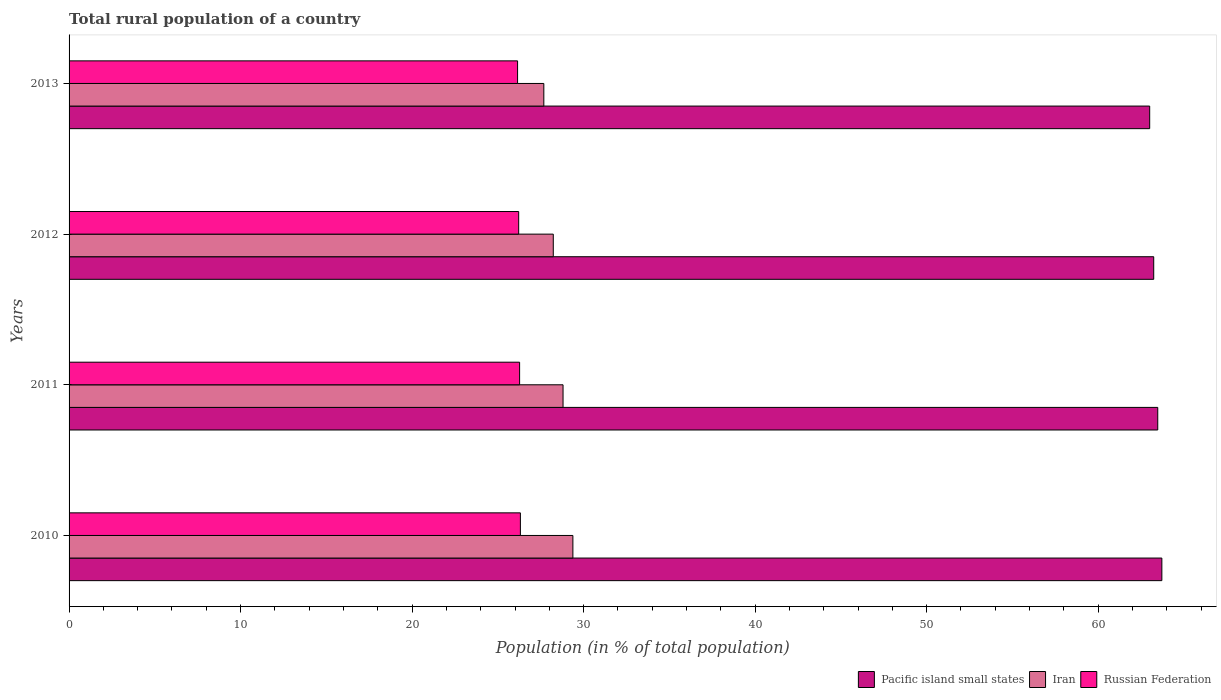What is the rural population in Pacific island small states in 2010?
Your answer should be compact. 63.71. Across all years, what is the maximum rural population in Russian Federation?
Your response must be concise. 26.31. Across all years, what is the minimum rural population in Iran?
Make the answer very short. 27.68. In which year was the rural population in Pacific island small states maximum?
Offer a very short reply. 2010. What is the total rural population in Iran in the graph?
Ensure brevity in your answer.  114.09. What is the difference between the rural population in Russian Federation in 2010 and that in 2013?
Your response must be concise. 0.16. What is the difference between the rural population in Russian Federation in 2011 and the rural population in Pacific island small states in 2013?
Keep it short and to the point. -36.73. What is the average rural population in Russian Federation per year?
Provide a succinct answer. 26.24. In the year 2012, what is the difference between the rural population in Pacific island small states and rural population in Iran?
Your answer should be very brief. 35.01. In how many years, is the rural population in Pacific island small states greater than 62 %?
Your answer should be compact. 4. What is the ratio of the rural population in Russian Federation in 2012 to that in 2013?
Offer a terse response. 1. Is the rural population in Pacific island small states in 2012 less than that in 2013?
Your response must be concise. No. What is the difference between the highest and the second highest rural population in Pacific island small states?
Make the answer very short. 0.24. What is the difference between the highest and the lowest rural population in Pacific island small states?
Offer a terse response. 0.71. In how many years, is the rural population in Pacific island small states greater than the average rural population in Pacific island small states taken over all years?
Provide a short and direct response. 2. Is the sum of the rural population in Iran in 2010 and 2012 greater than the maximum rural population in Pacific island small states across all years?
Make the answer very short. No. What does the 3rd bar from the top in 2010 represents?
Your answer should be compact. Pacific island small states. What does the 2nd bar from the bottom in 2010 represents?
Offer a terse response. Iran. How many bars are there?
Give a very brief answer. 12. Are all the bars in the graph horizontal?
Your answer should be very brief. Yes. Are the values on the major ticks of X-axis written in scientific E-notation?
Offer a very short reply. No. Does the graph contain any zero values?
Your answer should be compact. No. Does the graph contain grids?
Make the answer very short. No. Where does the legend appear in the graph?
Your answer should be very brief. Bottom right. How are the legend labels stacked?
Offer a terse response. Horizontal. What is the title of the graph?
Give a very brief answer. Total rural population of a country. What is the label or title of the X-axis?
Ensure brevity in your answer.  Population (in % of total population). What is the Population (in % of total population) in Pacific island small states in 2010?
Provide a succinct answer. 63.71. What is the Population (in % of total population) in Iran in 2010?
Your answer should be compact. 29.37. What is the Population (in % of total population) in Russian Federation in 2010?
Your response must be concise. 26.31. What is the Population (in % of total population) of Pacific island small states in 2011?
Keep it short and to the point. 63.47. What is the Population (in % of total population) of Iran in 2011?
Make the answer very short. 28.8. What is the Population (in % of total population) of Russian Federation in 2011?
Offer a terse response. 26.27. What is the Population (in % of total population) of Pacific island small states in 2012?
Offer a terse response. 63.24. What is the Population (in % of total population) in Iran in 2012?
Provide a short and direct response. 28.23. What is the Population (in % of total population) in Russian Federation in 2012?
Give a very brief answer. 26.21. What is the Population (in % of total population) in Pacific island small states in 2013?
Provide a succinct answer. 63. What is the Population (in % of total population) in Iran in 2013?
Your response must be concise. 27.68. What is the Population (in % of total population) of Russian Federation in 2013?
Ensure brevity in your answer.  26.15. Across all years, what is the maximum Population (in % of total population) in Pacific island small states?
Your answer should be compact. 63.71. Across all years, what is the maximum Population (in % of total population) of Iran?
Offer a terse response. 29.37. Across all years, what is the maximum Population (in % of total population) of Russian Federation?
Offer a very short reply. 26.31. Across all years, what is the minimum Population (in % of total population) in Pacific island small states?
Ensure brevity in your answer.  63. Across all years, what is the minimum Population (in % of total population) of Iran?
Ensure brevity in your answer.  27.68. Across all years, what is the minimum Population (in % of total population) of Russian Federation?
Offer a very short reply. 26.15. What is the total Population (in % of total population) of Pacific island small states in the graph?
Offer a terse response. 253.43. What is the total Population (in % of total population) of Iran in the graph?
Your answer should be very brief. 114.08. What is the total Population (in % of total population) in Russian Federation in the graph?
Make the answer very short. 104.94. What is the difference between the Population (in % of total population) of Pacific island small states in 2010 and that in 2011?
Give a very brief answer. 0.24. What is the difference between the Population (in % of total population) in Iran in 2010 and that in 2011?
Offer a very short reply. 0.57. What is the difference between the Population (in % of total population) of Russian Federation in 2010 and that in 2011?
Offer a terse response. 0.04. What is the difference between the Population (in % of total population) of Pacific island small states in 2010 and that in 2012?
Your answer should be compact. 0.47. What is the difference between the Population (in % of total population) in Iran in 2010 and that in 2012?
Make the answer very short. 1.14. What is the difference between the Population (in % of total population) of Russian Federation in 2010 and that in 2012?
Your answer should be very brief. 0.1. What is the difference between the Population (in % of total population) in Pacific island small states in 2010 and that in 2013?
Make the answer very short. 0.71. What is the difference between the Population (in % of total population) in Iran in 2010 and that in 2013?
Offer a very short reply. 1.69. What is the difference between the Population (in % of total population) of Russian Federation in 2010 and that in 2013?
Provide a short and direct response. 0.16. What is the difference between the Population (in % of total population) of Pacific island small states in 2011 and that in 2012?
Provide a short and direct response. 0.24. What is the difference between the Population (in % of total population) of Iran in 2011 and that in 2012?
Offer a very short reply. 0.57. What is the difference between the Population (in % of total population) of Russian Federation in 2011 and that in 2012?
Make the answer very short. 0.05. What is the difference between the Population (in % of total population) of Pacific island small states in 2011 and that in 2013?
Your response must be concise. 0.47. What is the difference between the Population (in % of total population) of Iran in 2011 and that in 2013?
Your response must be concise. 1.12. What is the difference between the Population (in % of total population) in Russian Federation in 2011 and that in 2013?
Ensure brevity in your answer.  0.12. What is the difference between the Population (in % of total population) of Pacific island small states in 2012 and that in 2013?
Provide a short and direct response. 0.23. What is the difference between the Population (in % of total population) of Iran in 2012 and that in 2013?
Make the answer very short. 0.55. What is the difference between the Population (in % of total population) of Russian Federation in 2012 and that in 2013?
Offer a terse response. 0.07. What is the difference between the Population (in % of total population) in Pacific island small states in 2010 and the Population (in % of total population) in Iran in 2011?
Offer a terse response. 34.91. What is the difference between the Population (in % of total population) of Pacific island small states in 2010 and the Population (in % of total population) of Russian Federation in 2011?
Give a very brief answer. 37.44. What is the difference between the Population (in % of total population) in Iran in 2010 and the Population (in % of total population) in Russian Federation in 2011?
Your answer should be compact. 3.11. What is the difference between the Population (in % of total population) in Pacific island small states in 2010 and the Population (in % of total population) in Iran in 2012?
Ensure brevity in your answer.  35.48. What is the difference between the Population (in % of total population) of Pacific island small states in 2010 and the Population (in % of total population) of Russian Federation in 2012?
Keep it short and to the point. 37.5. What is the difference between the Population (in % of total population) in Iran in 2010 and the Population (in % of total population) in Russian Federation in 2012?
Offer a terse response. 3.16. What is the difference between the Population (in % of total population) of Pacific island small states in 2010 and the Population (in % of total population) of Iran in 2013?
Your response must be concise. 36.03. What is the difference between the Population (in % of total population) in Pacific island small states in 2010 and the Population (in % of total population) in Russian Federation in 2013?
Offer a very short reply. 37.56. What is the difference between the Population (in % of total population) in Iran in 2010 and the Population (in % of total population) in Russian Federation in 2013?
Provide a succinct answer. 3.23. What is the difference between the Population (in % of total population) of Pacific island small states in 2011 and the Population (in % of total population) of Iran in 2012?
Keep it short and to the point. 35.24. What is the difference between the Population (in % of total population) in Pacific island small states in 2011 and the Population (in % of total population) in Russian Federation in 2012?
Give a very brief answer. 37.26. What is the difference between the Population (in % of total population) in Iran in 2011 and the Population (in % of total population) in Russian Federation in 2012?
Keep it short and to the point. 2.59. What is the difference between the Population (in % of total population) of Pacific island small states in 2011 and the Population (in % of total population) of Iran in 2013?
Give a very brief answer. 35.79. What is the difference between the Population (in % of total population) in Pacific island small states in 2011 and the Population (in % of total population) in Russian Federation in 2013?
Make the answer very short. 37.32. What is the difference between the Population (in % of total population) in Iran in 2011 and the Population (in % of total population) in Russian Federation in 2013?
Your response must be concise. 2.65. What is the difference between the Population (in % of total population) of Pacific island small states in 2012 and the Population (in % of total population) of Iran in 2013?
Keep it short and to the point. 35.56. What is the difference between the Population (in % of total population) of Pacific island small states in 2012 and the Population (in % of total population) of Russian Federation in 2013?
Keep it short and to the point. 37.09. What is the difference between the Population (in % of total population) in Iran in 2012 and the Population (in % of total population) in Russian Federation in 2013?
Make the answer very short. 2.08. What is the average Population (in % of total population) in Pacific island small states per year?
Offer a terse response. 63.36. What is the average Population (in % of total population) of Iran per year?
Provide a short and direct response. 28.52. What is the average Population (in % of total population) in Russian Federation per year?
Your answer should be very brief. 26.24. In the year 2010, what is the difference between the Population (in % of total population) in Pacific island small states and Population (in % of total population) in Iran?
Your answer should be compact. 34.34. In the year 2010, what is the difference between the Population (in % of total population) of Pacific island small states and Population (in % of total population) of Russian Federation?
Your response must be concise. 37.4. In the year 2010, what is the difference between the Population (in % of total population) of Iran and Population (in % of total population) of Russian Federation?
Provide a short and direct response. 3.06. In the year 2011, what is the difference between the Population (in % of total population) of Pacific island small states and Population (in % of total population) of Iran?
Keep it short and to the point. 34.67. In the year 2011, what is the difference between the Population (in % of total population) in Pacific island small states and Population (in % of total population) in Russian Federation?
Offer a very short reply. 37.21. In the year 2011, what is the difference between the Population (in % of total population) in Iran and Population (in % of total population) in Russian Federation?
Offer a terse response. 2.53. In the year 2012, what is the difference between the Population (in % of total population) in Pacific island small states and Population (in % of total population) in Iran?
Keep it short and to the point. 35.01. In the year 2012, what is the difference between the Population (in % of total population) in Pacific island small states and Population (in % of total population) in Russian Federation?
Keep it short and to the point. 37.02. In the year 2012, what is the difference between the Population (in % of total population) of Iran and Population (in % of total population) of Russian Federation?
Give a very brief answer. 2.02. In the year 2013, what is the difference between the Population (in % of total population) of Pacific island small states and Population (in % of total population) of Iran?
Your response must be concise. 35.32. In the year 2013, what is the difference between the Population (in % of total population) of Pacific island small states and Population (in % of total population) of Russian Federation?
Offer a terse response. 36.85. In the year 2013, what is the difference between the Population (in % of total population) in Iran and Population (in % of total population) in Russian Federation?
Offer a very short reply. 1.53. What is the ratio of the Population (in % of total population) of Iran in 2010 to that in 2011?
Provide a succinct answer. 1.02. What is the ratio of the Population (in % of total population) of Russian Federation in 2010 to that in 2011?
Your answer should be very brief. 1. What is the ratio of the Population (in % of total population) in Pacific island small states in 2010 to that in 2012?
Make the answer very short. 1.01. What is the ratio of the Population (in % of total population) in Iran in 2010 to that in 2012?
Your answer should be very brief. 1.04. What is the ratio of the Population (in % of total population) in Pacific island small states in 2010 to that in 2013?
Ensure brevity in your answer.  1.01. What is the ratio of the Population (in % of total population) in Iran in 2010 to that in 2013?
Your answer should be very brief. 1.06. What is the ratio of the Population (in % of total population) of Russian Federation in 2010 to that in 2013?
Your response must be concise. 1.01. What is the ratio of the Population (in % of total population) of Pacific island small states in 2011 to that in 2012?
Your response must be concise. 1. What is the ratio of the Population (in % of total population) of Iran in 2011 to that in 2012?
Give a very brief answer. 1.02. What is the ratio of the Population (in % of total population) in Pacific island small states in 2011 to that in 2013?
Offer a very short reply. 1.01. What is the ratio of the Population (in % of total population) of Iran in 2011 to that in 2013?
Provide a succinct answer. 1.04. What is the ratio of the Population (in % of total population) of Iran in 2012 to that in 2013?
Keep it short and to the point. 1.02. What is the difference between the highest and the second highest Population (in % of total population) in Pacific island small states?
Provide a short and direct response. 0.24. What is the difference between the highest and the second highest Population (in % of total population) in Iran?
Offer a very short reply. 0.57. What is the difference between the highest and the second highest Population (in % of total population) of Russian Federation?
Make the answer very short. 0.04. What is the difference between the highest and the lowest Population (in % of total population) of Pacific island small states?
Offer a terse response. 0.71. What is the difference between the highest and the lowest Population (in % of total population) in Iran?
Your answer should be compact. 1.69. What is the difference between the highest and the lowest Population (in % of total population) of Russian Federation?
Give a very brief answer. 0.16. 